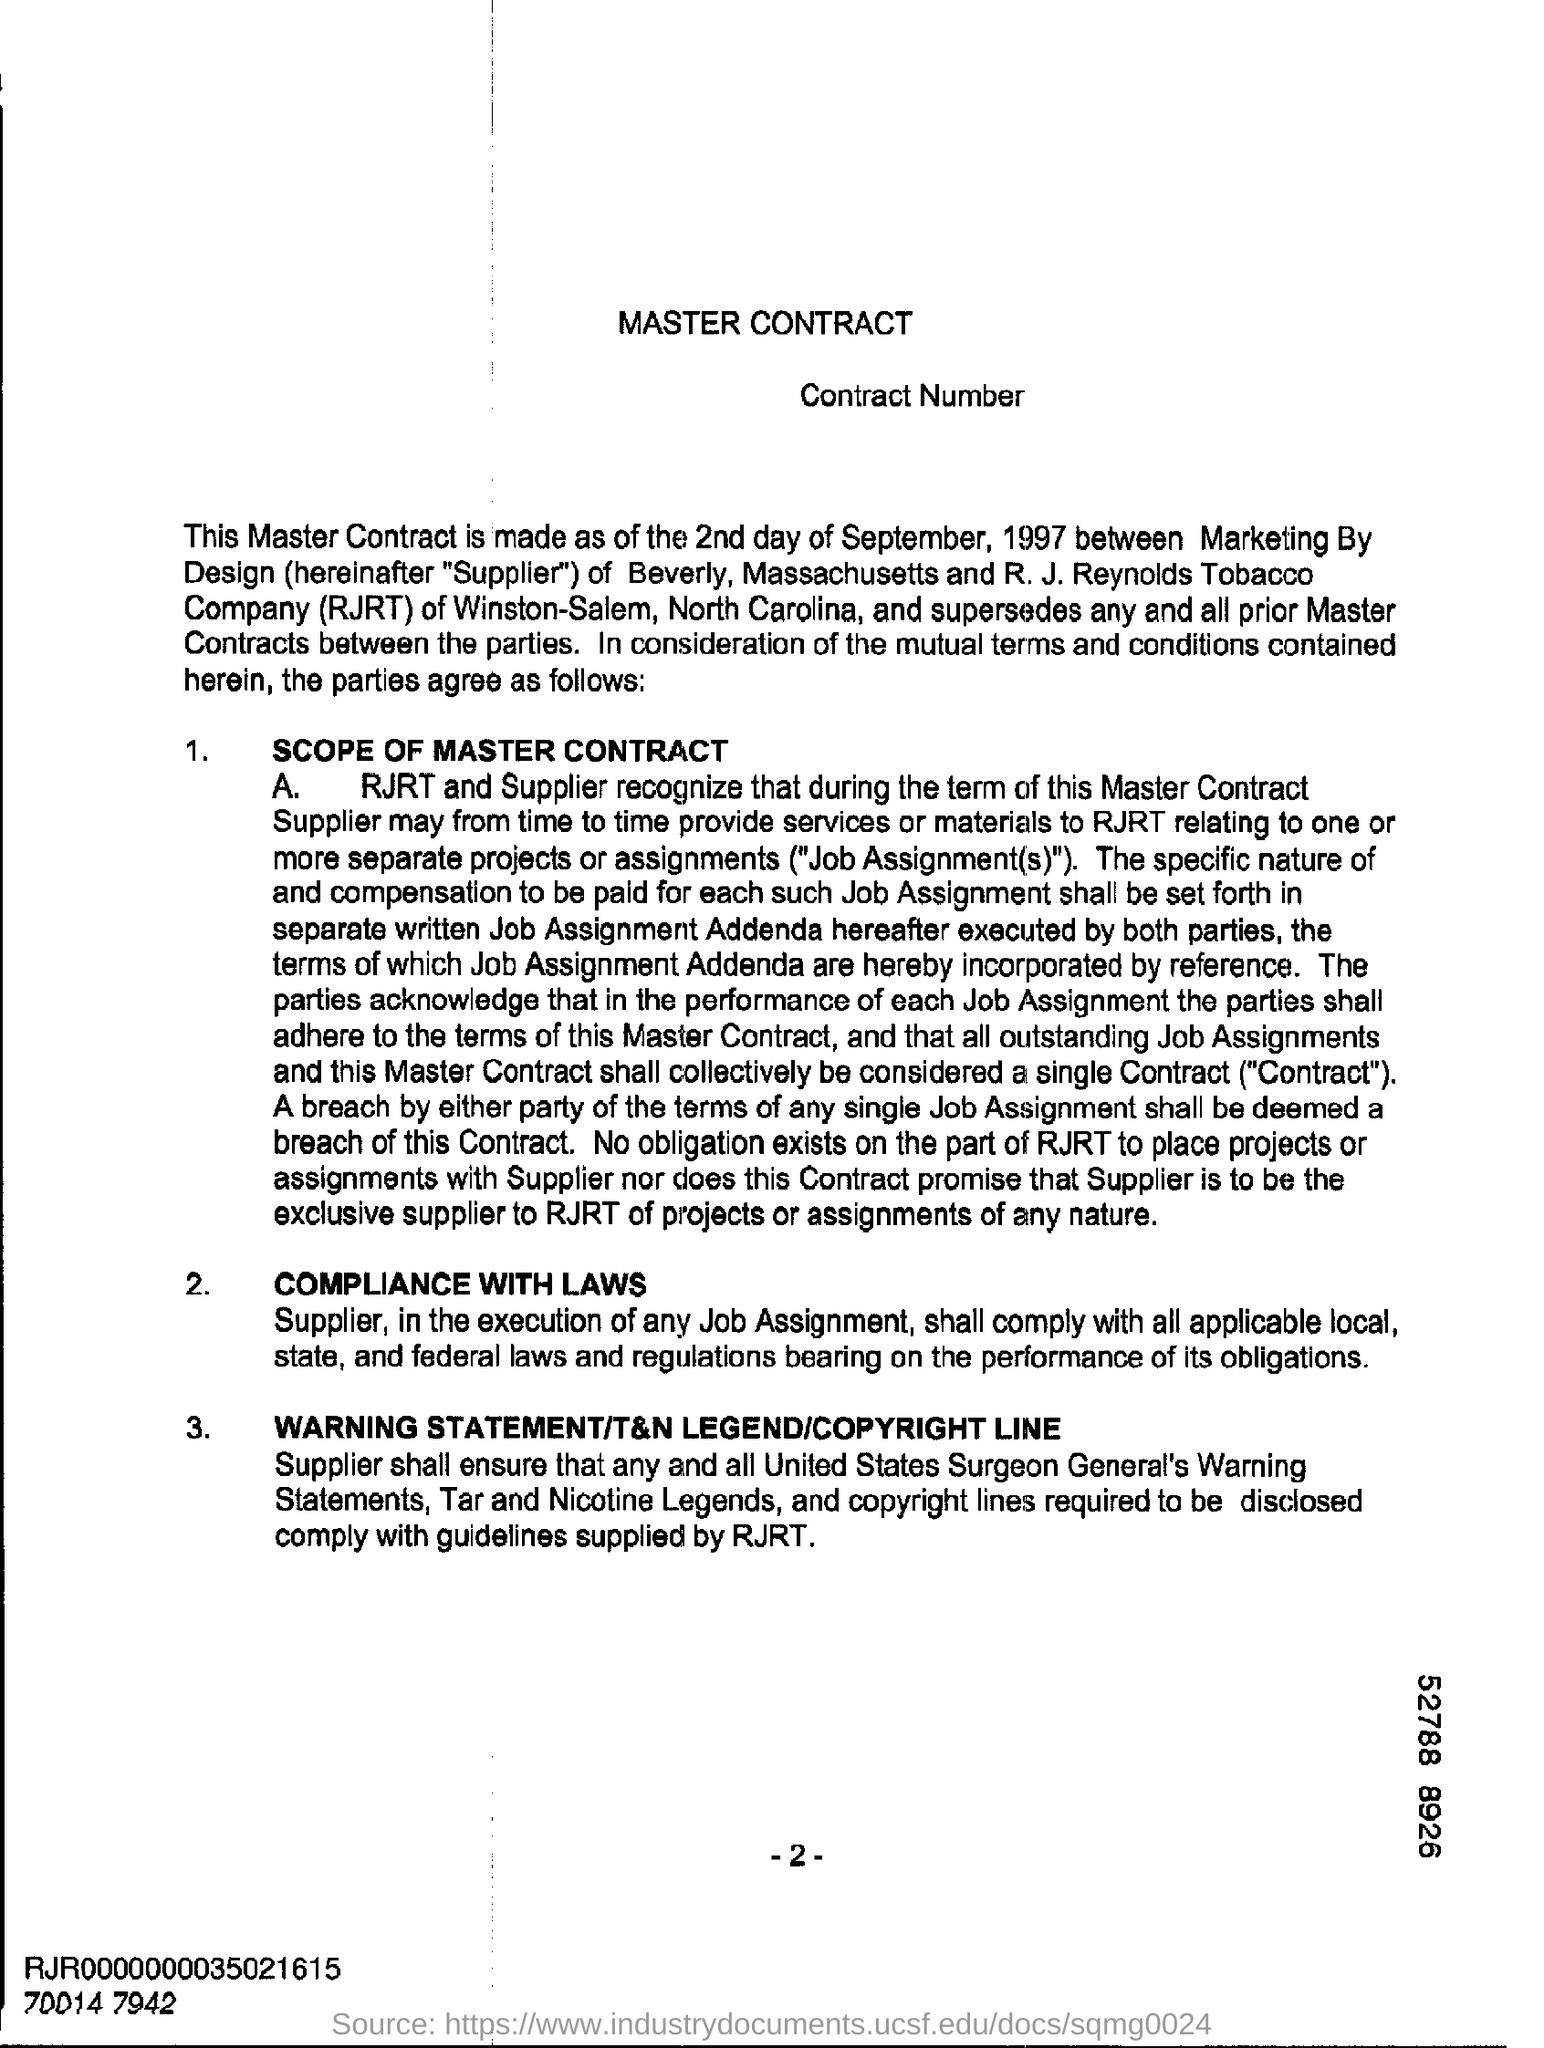List a handful of essential elements in this visual. The number at the bottom of the page is -2. The heading at the top of the page is 'Master Contract.' 